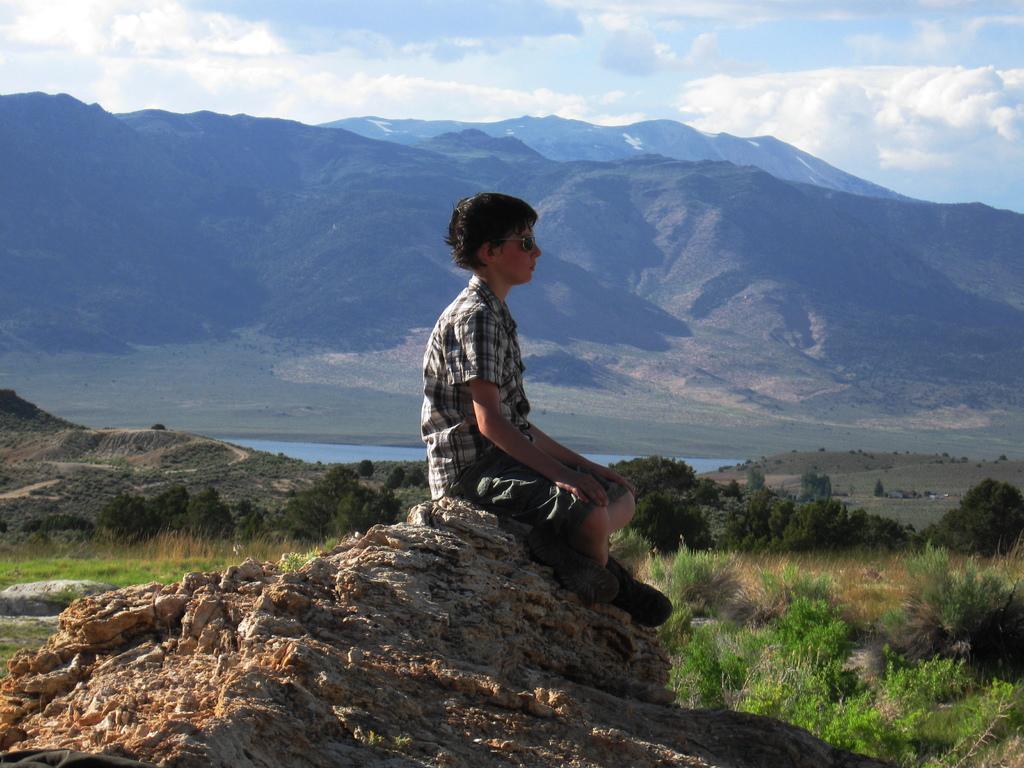Can you describe this image briefly? In this image we can see a person wearing goggles is sitting on the surface. In the center of the image we can see water, grass and a group of trees. In the background, we can see group of mountains and the cloudy sky. 